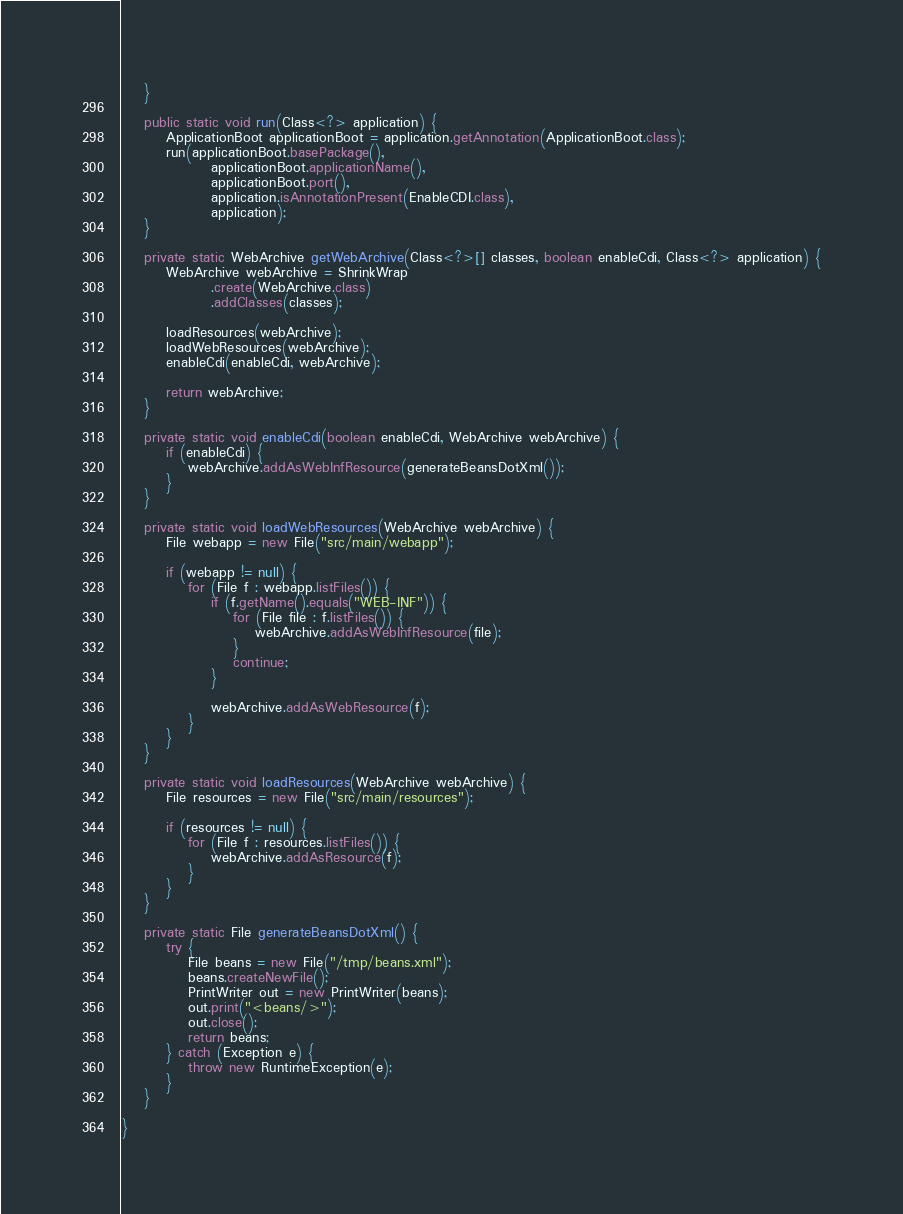<code> <loc_0><loc_0><loc_500><loc_500><_Java_>    }

    public static void run(Class<?> application) {
        ApplicationBoot applicationBoot = application.getAnnotation(ApplicationBoot.class);
        run(applicationBoot.basePackage(),
                applicationBoot.applicationName(),
                applicationBoot.port(),
                application.isAnnotationPresent(EnableCDI.class),
                application);
    }

    private static WebArchive getWebArchive(Class<?>[] classes, boolean enableCdi, Class<?> application) {
        WebArchive webArchive = ShrinkWrap
                .create(WebArchive.class)
                .addClasses(classes);

        loadResources(webArchive);
        loadWebResources(webArchive);
        enableCdi(enableCdi, webArchive);

        return webArchive;
    }

    private static void enableCdi(boolean enableCdi, WebArchive webArchive) {
        if (enableCdi) {
            webArchive.addAsWebInfResource(generateBeansDotXml());
        }
    }

    private static void loadWebResources(WebArchive webArchive) {
        File webapp = new File("src/main/webapp");

        if (webapp != null) {
            for (File f : webapp.listFiles()) {
                if (f.getName().equals("WEB-INF")) {
                    for (File file : f.listFiles()) {
                        webArchive.addAsWebInfResource(file);
                    }
                    continue;
                }

                webArchive.addAsWebResource(f);
            }
        }
    }

    private static void loadResources(WebArchive webArchive) {
        File resources = new File("src/main/resources");

        if (resources != null) {
            for (File f : resources.listFiles()) {
                webArchive.addAsResource(f);
            }
        }
    }

    private static File generateBeansDotXml() {
        try {
            File beans = new File("/tmp/beans.xml");
            beans.createNewFile();
            PrintWriter out = new PrintWriter(beans);
            out.print("<beans/>");
            out.close();
            return beans;
        } catch (Exception e) {
            throw new RuntimeException(e);
        }
    }

}
</code> 